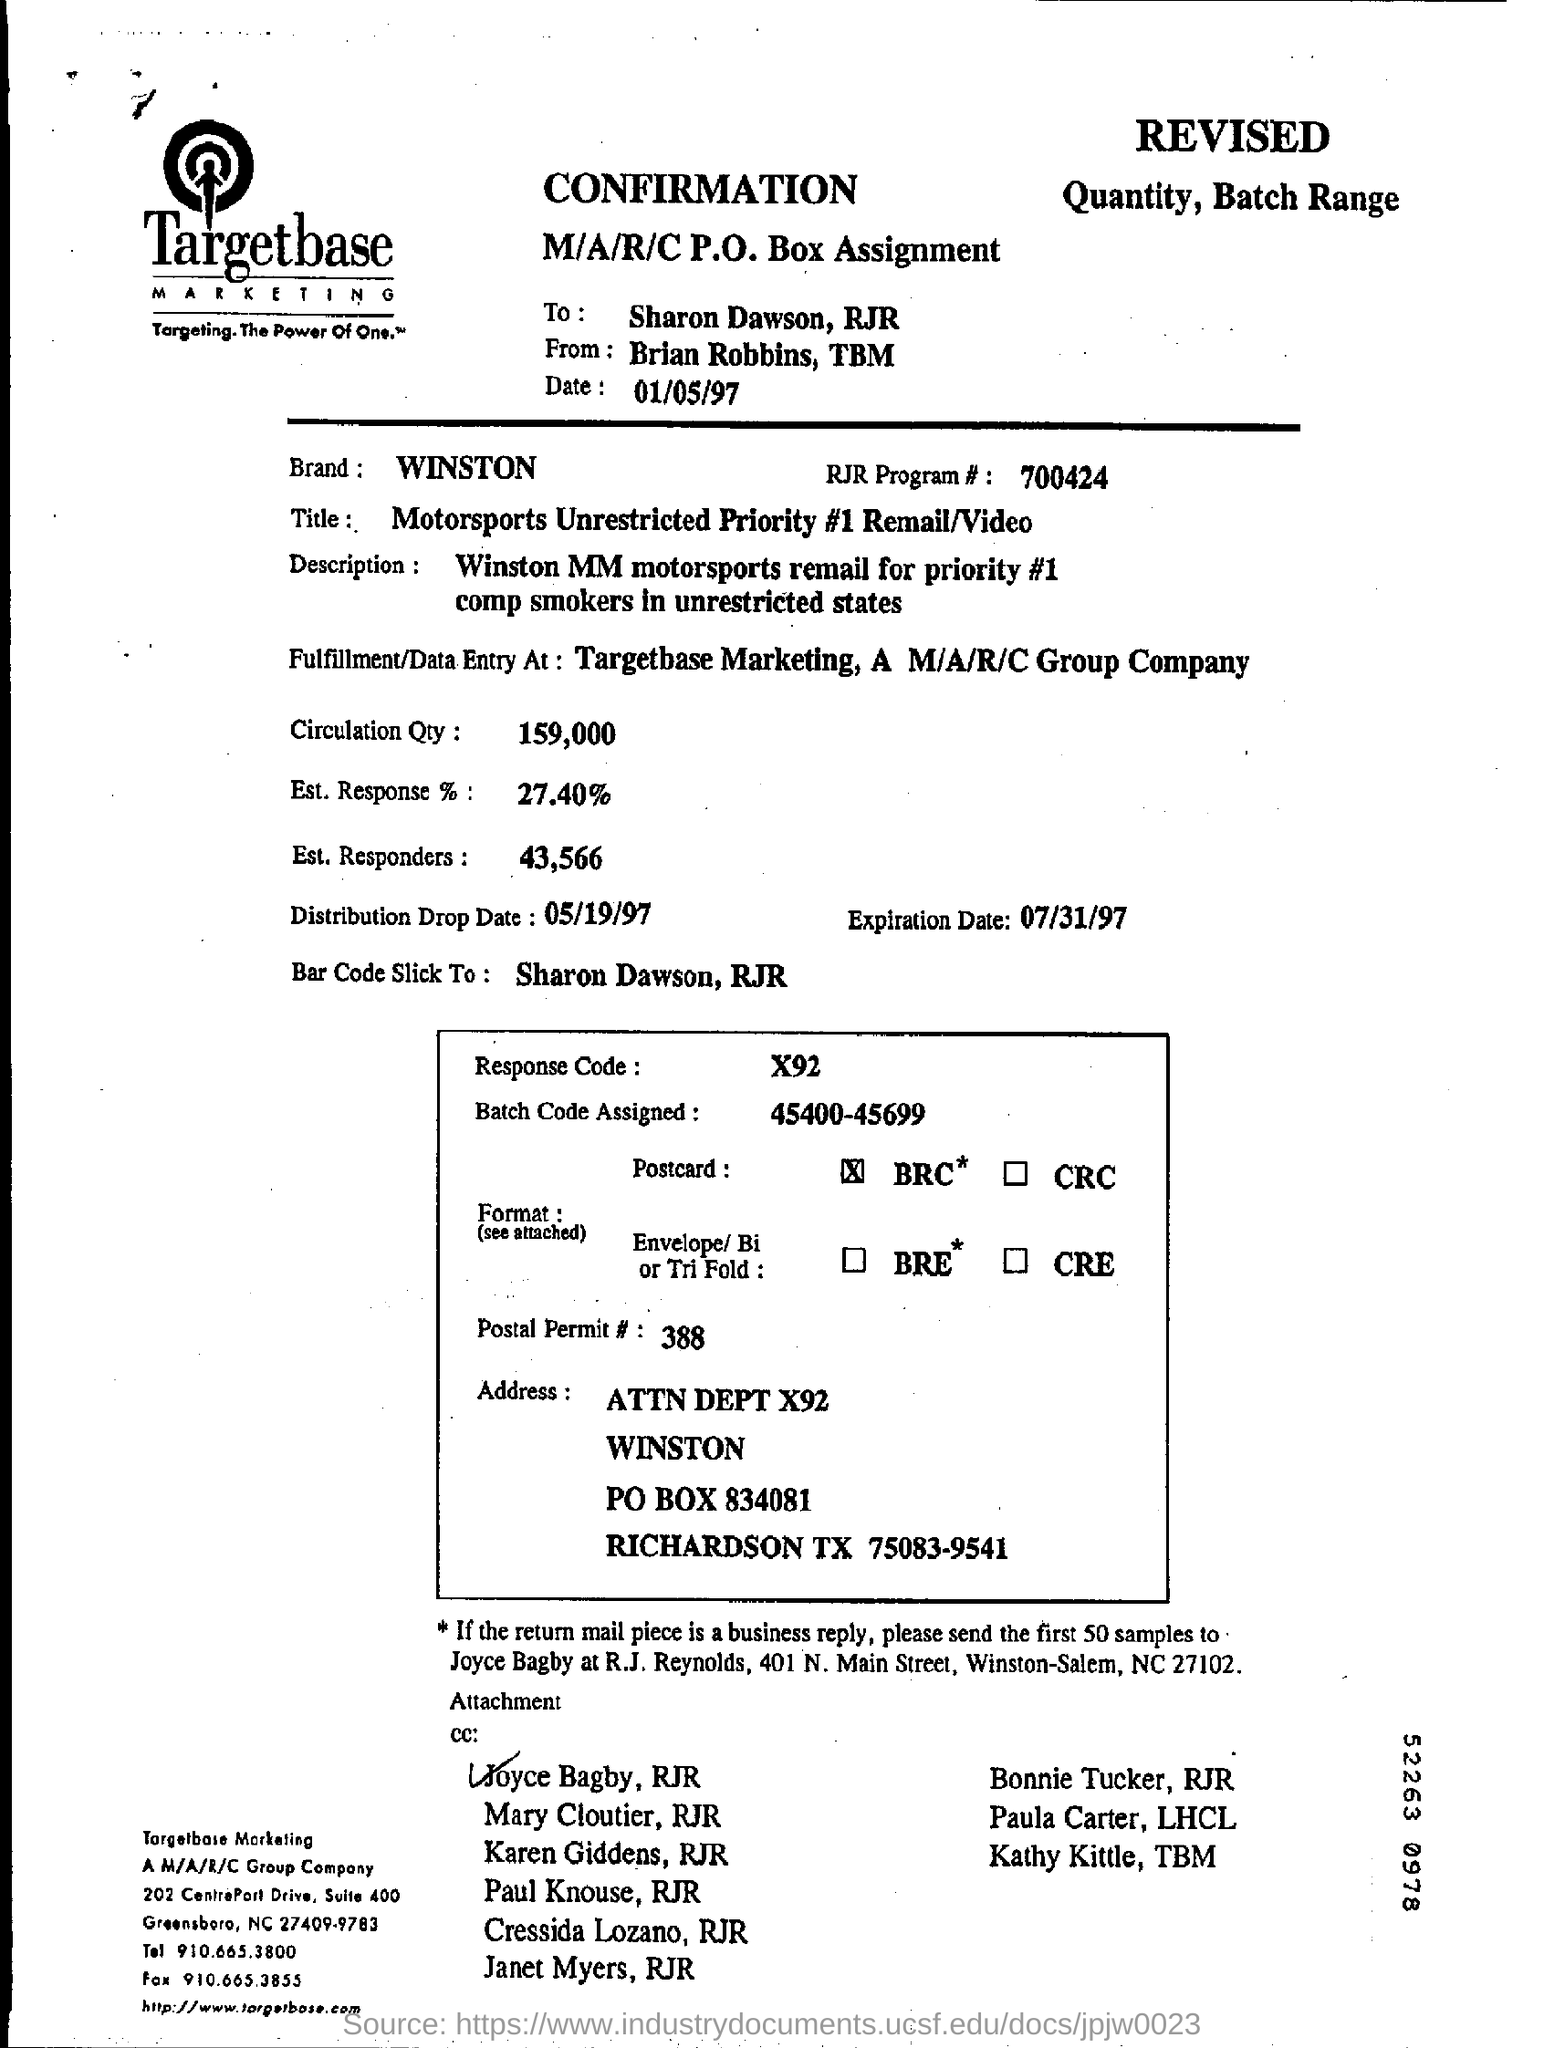What is the name of the marketing company?
Offer a very short reply. Targetbase Marketing. What is the name ticked at the bottom of this document?
Give a very brief answer. Joyce Bagby, RJR. What is the RJR Program # number?
Provide a short and direct response. 700424. 